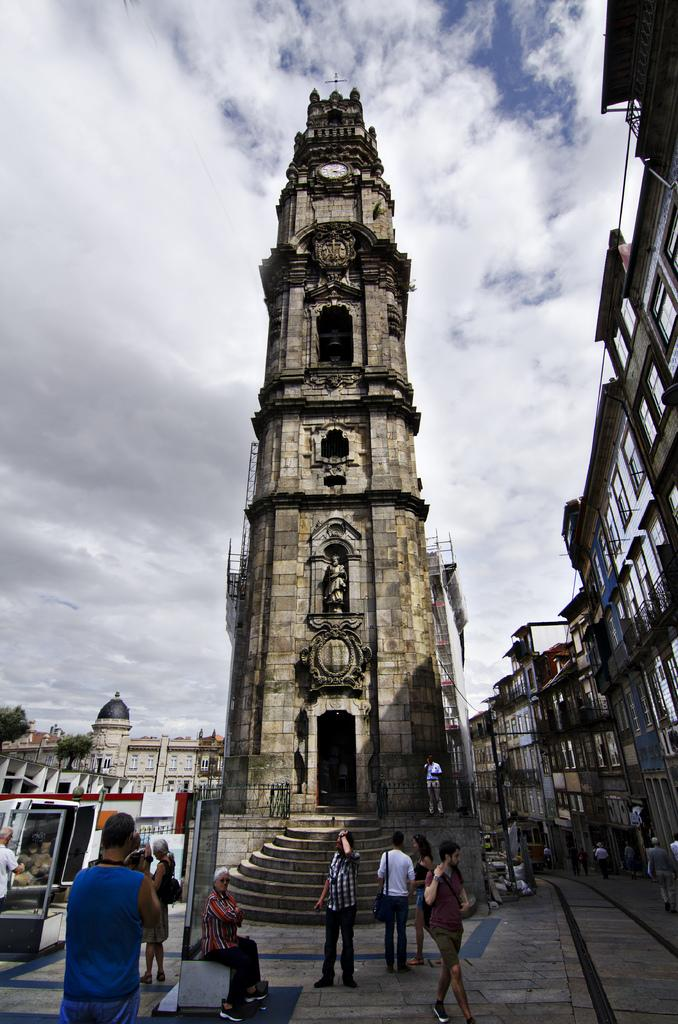How many people are in the image? There is a group of people in the image, but the exact number is not specified. What are the people in the image doing? Some people are seated, and some are standing. What can be seen in the background of the image? There are buildings and trees in the background of the image. What type of toy is being used by the people in the image? There is no toy present in the image; the people are either seated or standing. How would you describe the texture of the trees in the background? The texture of the trees cannot be determined from the image alone, as it only provides visual information. 